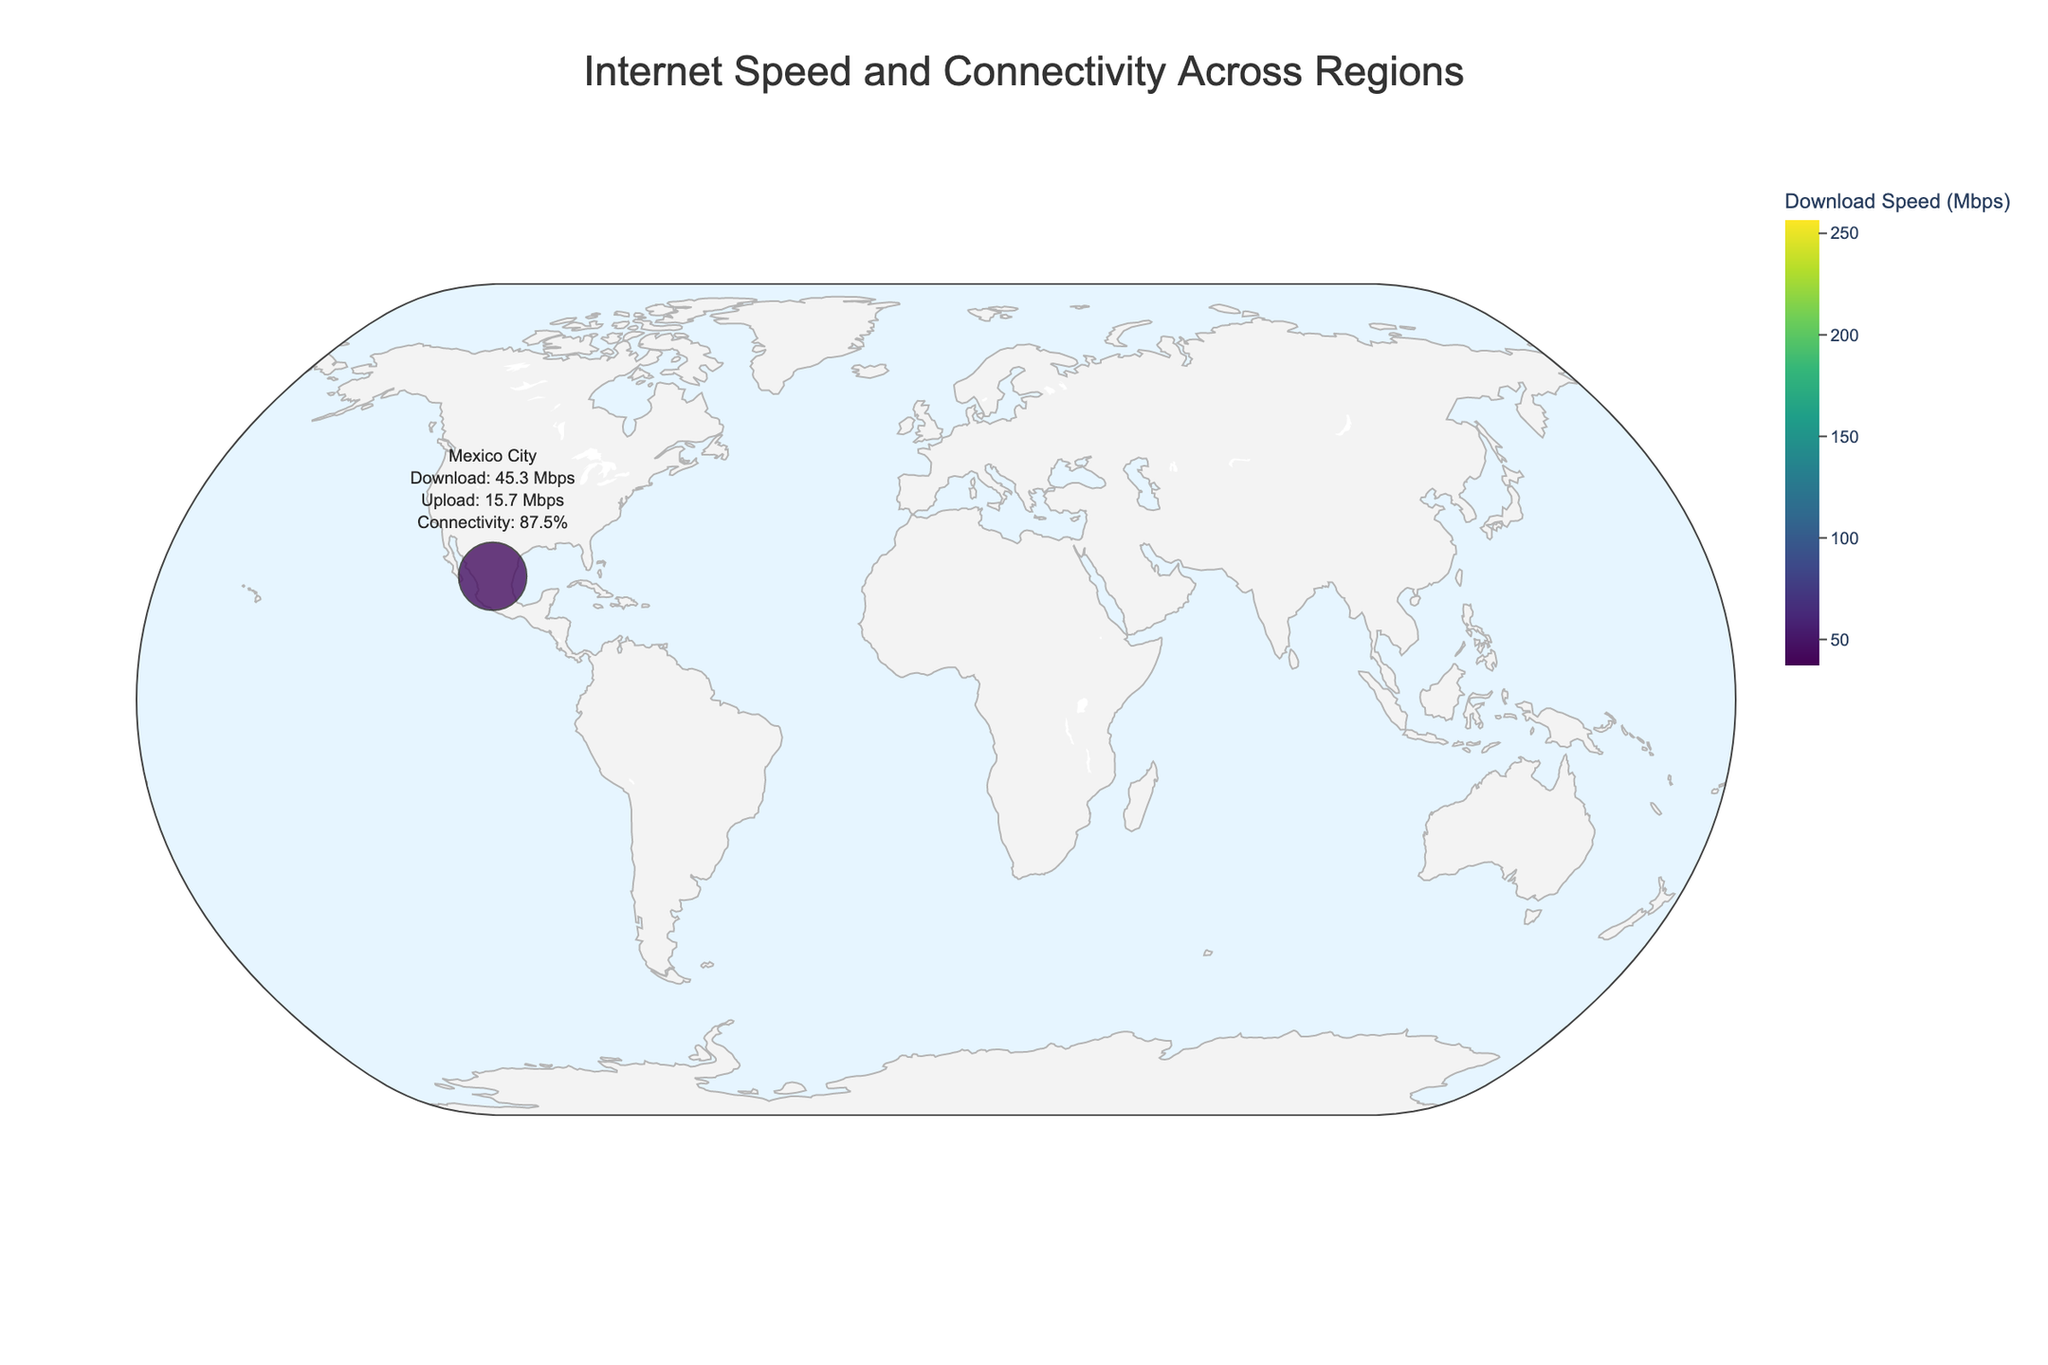What is the title of the plot? The title is usually located at the top of the plot and provides an overview of what the plot represents.
Answer: Internet Speed and Connectivity Across Regions Which region has the highest average download speed? By scanning the color legend, Seoul shows the darkest color, indicating the highest download speed.
Answer: Seoul What is the connectivity rate for San Francisco? Hovering over or examining San Francisco in the plot reveals its connectivity rate.
Answer: 97.9% What is the average upload speed for Singapore? Hovering over or examining the text associated with Singapore in the plot reveals the upload speed.
Answer: 207.1 Mbps Which region has the lowest average upload speed? By looking for the lightest color or by checking regions individually, Sydney shows the lowest upload speed.
Answer: Sydney How many regions have a connectivity rate higher than 95%? Scanning the plot for each region and counting those with a connectivity rate over 95% yields the answer.
Answer: 9 regions (New York City, San Francisco, London, Tokyo, Seoul, Singapore, Amsterdam, Paris, Toronto) Which region has the smallest marker size on the plot, and what does it indicate? The smallest size corresponds to the region with the lowest connectivity rate, identified by examining marker sizes.
Answer: Mumbai, indicating the lowest connectivity rate Compare the average download speeds between New York City and Tokyo. Which is higher? By examining both regions' download speeds, New York City has a higher value than Tokyo.
Answer: New York City What are the average download and upload speeds for London? Hovering over London in the plot reveals its download and upload speeds.
Answer: 108.3 Mbps download, 51.6 Mbps upload Which region has a higher average upload speed, Moscow or Dubai? Comparing the uploaded speeds for Moscow and Dubai from the plot information, Moscow's upload speed is higher.
Answer: Moscow 